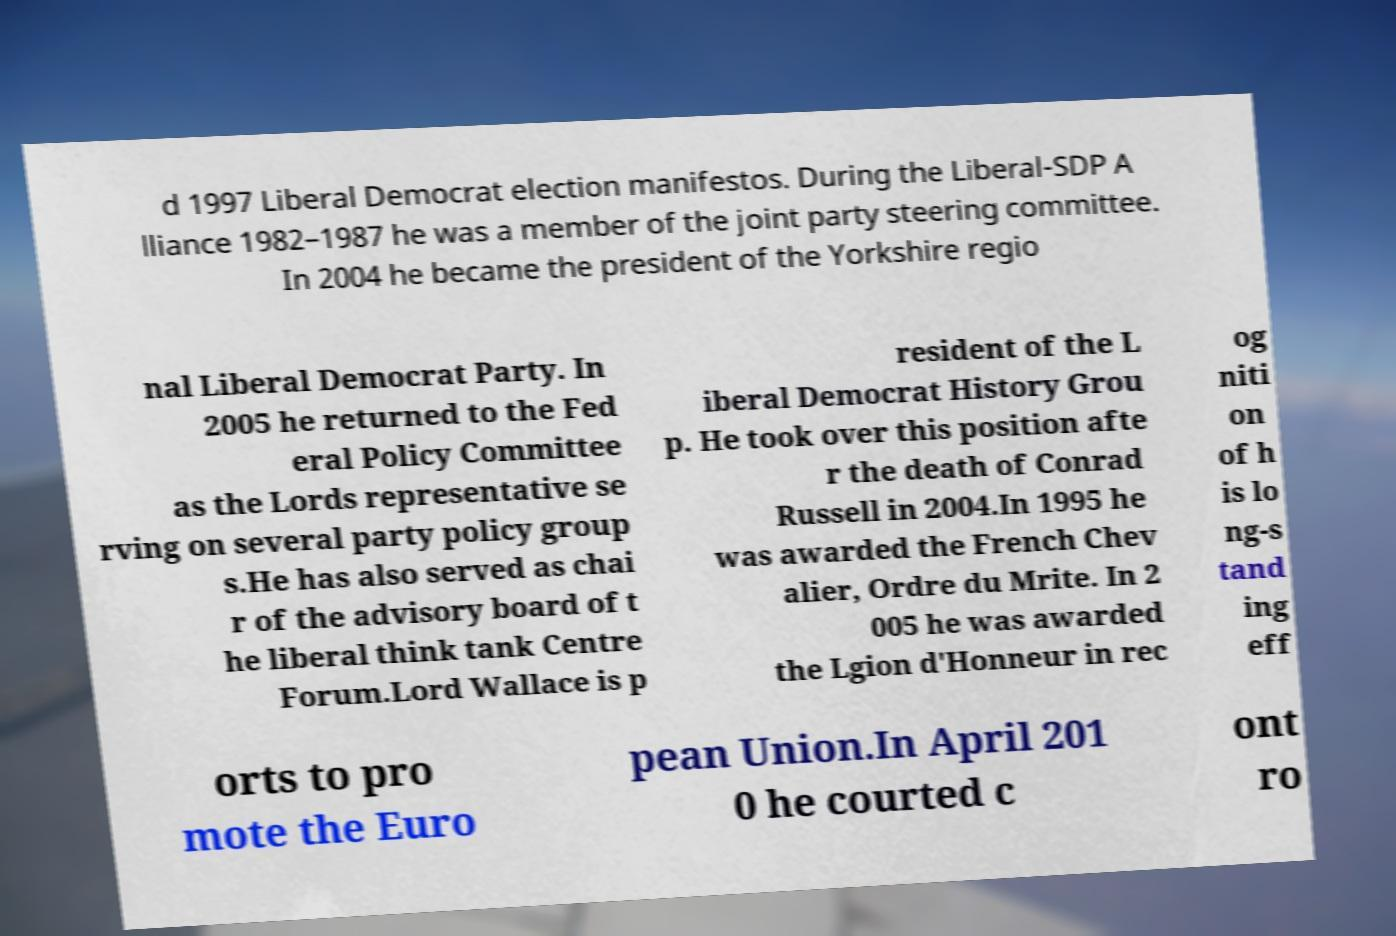I need the written content from this picture converted into text. Can you do that? d 1997 Liberal Democrat election manifestos. During the Liberal-SDP A lliance 1982–1987 he was a member of the joint party steering committee. In 2004 he became the president of the Yorkshire regio nal Liberal Democrat Party. In 2005 he returned to the Fed eral Policy Committee as the Lords representative se rving on several party policy group s.He has also served as chai r of the advisory board of t he liberal think tank Centre Forum.Lord Wallace is p resident of the L iberal Democrat History Grou p. He took over this position afte r the death of Conrad Russell in 2004.In 1995 he was awarded the French Chev alier, Ordre du Mrite. In 2 005 he was awarded the Lgion d'Honneur in rec og niti on of h is lo ng-s tand ing eff orts to pro mote the Euro pean Union.In April 201 0 he courted c ont ro 